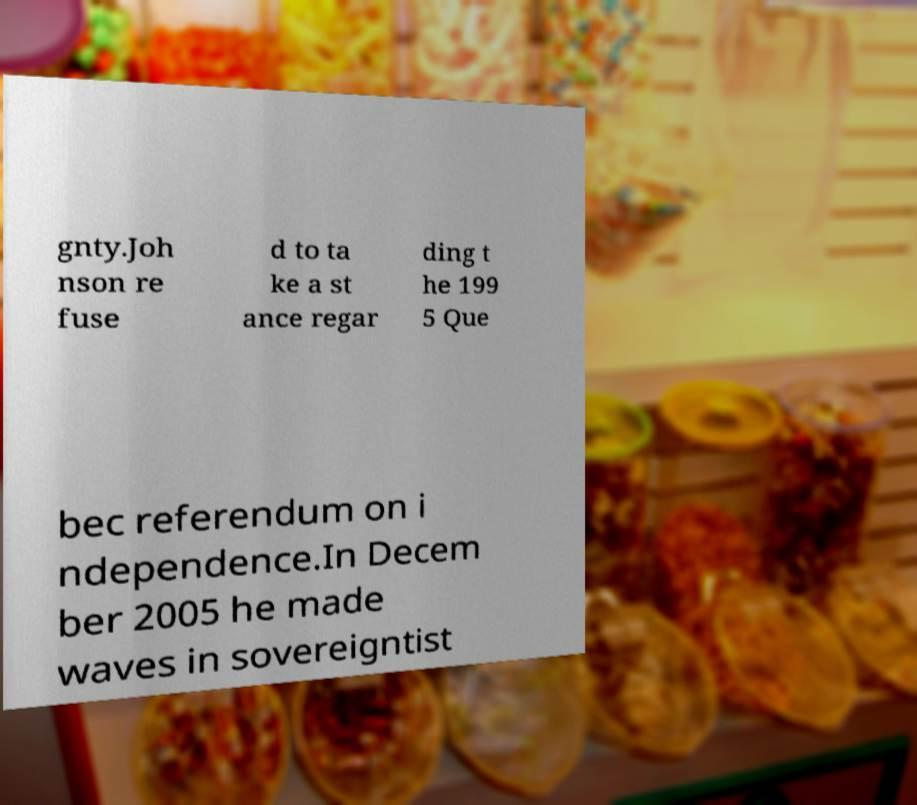Could you assist in decoding the text presented in this image and type it out clearly? gnty.Joh nson re fuse d to ta ke a st ance regar ding t he 199 5 Que bec referendum on i ndependence.In Decem ber 2005 he made waves in sovereigntist 